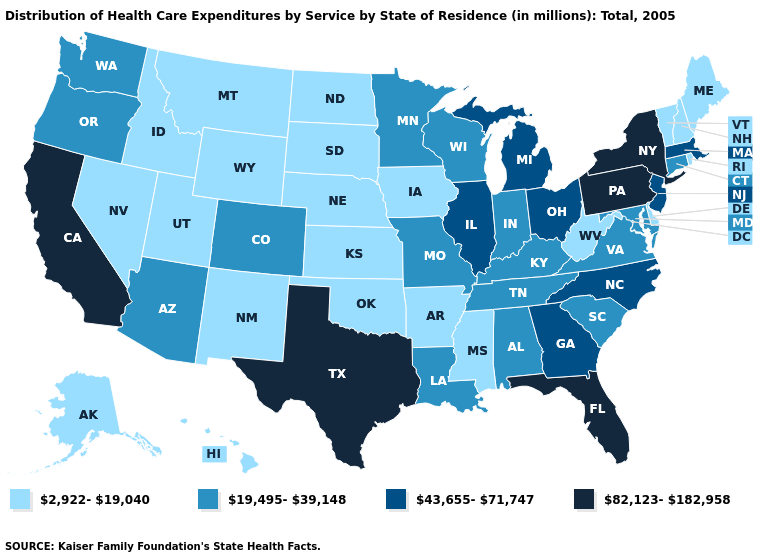Among the states that border Georgia , does South Carolina have the highest value?
Keep it brief. No. Name the states that have a value in the range 43,655-71,747?
Keep it brief. Georgia, Illinois, Massachusetts, Michigan, New Jersey, North Carolina, Ohio. What is the value of Arkansas?
Answer briefly. 2,922-19,040. Which states hav the highest value in the South?
Be succinct. Florida, Texas. Does New York have the highest value in the USA?
Concise answer only. Yes. What is the lowest value in the MidWest?
Be succinct. 2,922-19,040. What is the value of Kentucky?
Write a very short answer. 19,495-39,148. Which states have the lowest value in the USA?
Short answer required. Alaska, Arkansas, Delaware, Hawaii, Idaho, Iowa, Kansas, Maine, Mississippi, Montana, Nebraska, Nevada, New Hampshire, New Mexico, North Dakota, Oklahoma, Rhode Island, South Dakota, Utah, Vermont, West Virginia, Wyoming. What is the value of Hawaii?
Give a very brief answer. 2,922-19,040. Does Minnesota have the lowest value in the USA?
Give a very brief answer. No. Which states have the lowest value in the USA?
Short answer required. Alaska, Arkansas, Delaware, Hawaii, Idaho, Iowa, Kansas, Maine, Mississippi, Montana, Nebraska, Nevada, New Hampshire, New Mexico, North Dakota, Oklahoma, Rhode Island, South Dakota, Utah, Vermont, West Virginia, Wyoming. How many symbols are there in the legend?
Short answer required. 4. Name the states that have a value in the range 82,123-182,958?
Quick response, please. California, Florida, New York, Pennsylvania, Texas. Does Oklahoma have the lowest value in the USA?
Short answer required. Yes. Among the states that border Iowa , does Nebraska have the lowest value?
Keep it brief. Yes. 